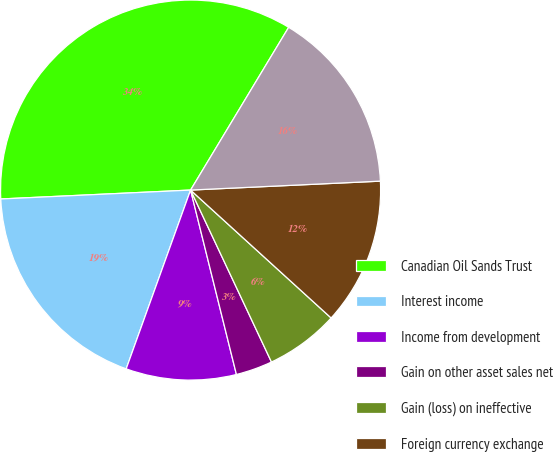Convert chart to OTSL. <chart><loc_0><loc_0><loc_500><loc_500><pie_chart><fcel>Canadian Oil Sands Trust<fcel>Interest income<fcel>Income from development<fcel>Gain on other asset sales net<fcel>Gain (loss) on ineffective<fcel>Foreign currency exchange<fcel>Other<nl><fcel>34.38%<fcel>18.75%<fcel>9.38%<fcel>3.12%<fcel>6.25%<fcel>12.5%<fcel>15.62%<nl></chart> 